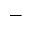<formula> <loc_0><loc_0><loc_500><loc_500>-</formula> 